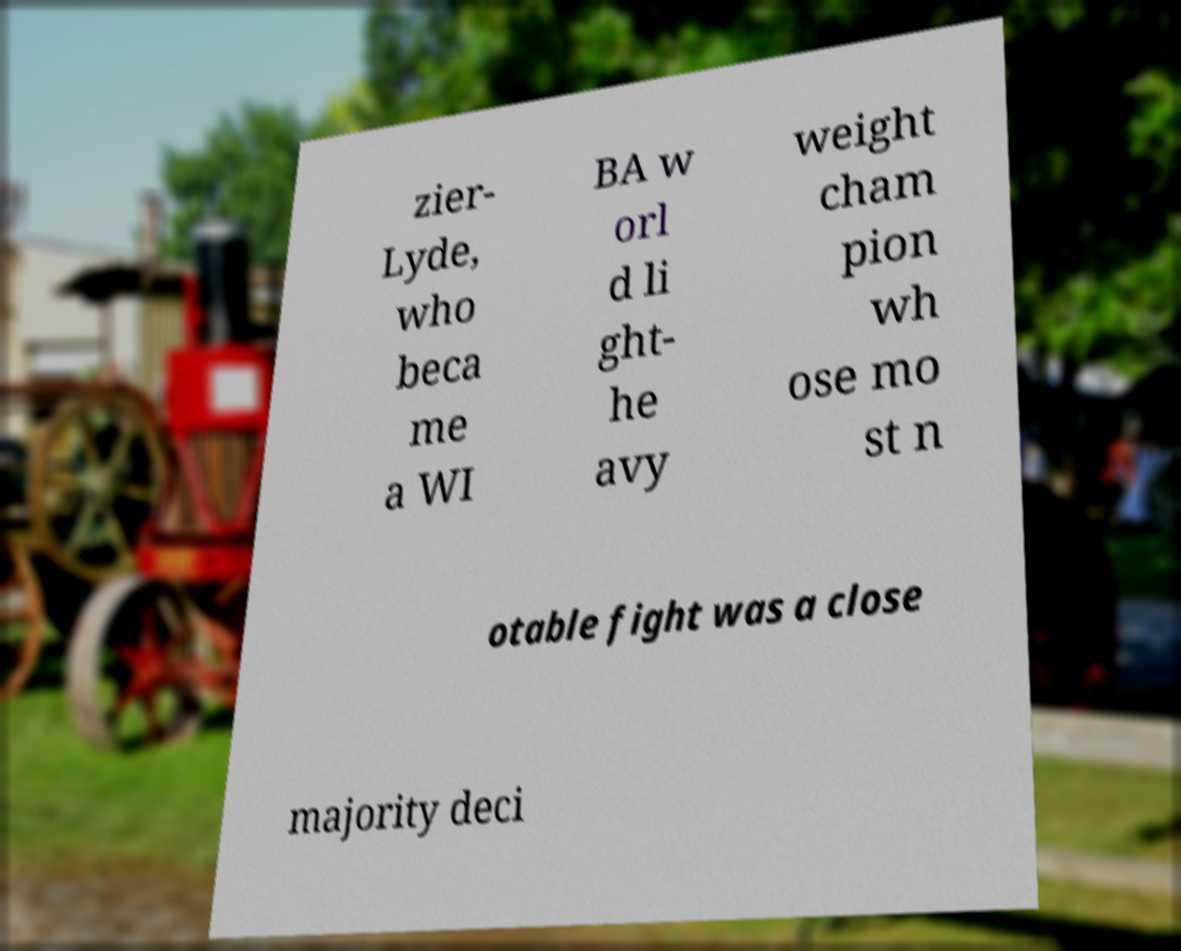What messages or text are displayed in this image? I need them in a readable, typed format. zier- Lyde, who beca me a WI BA w orl d li ght- he avy weight cham pion wh ose mo st n otable fight was a close majority deci 